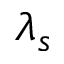Convert formula to latex. <formula><loc_0><loc_0><loc_500><loc_500>\lambda _ { s }</formula> 